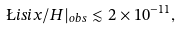<formula> <loc_0><loc_0><loc_500><loc_500>\L i s i x / H | _ { o b s } \lesssim 2 \times 1 0 ^ { - 1 1 } ,</formula> 